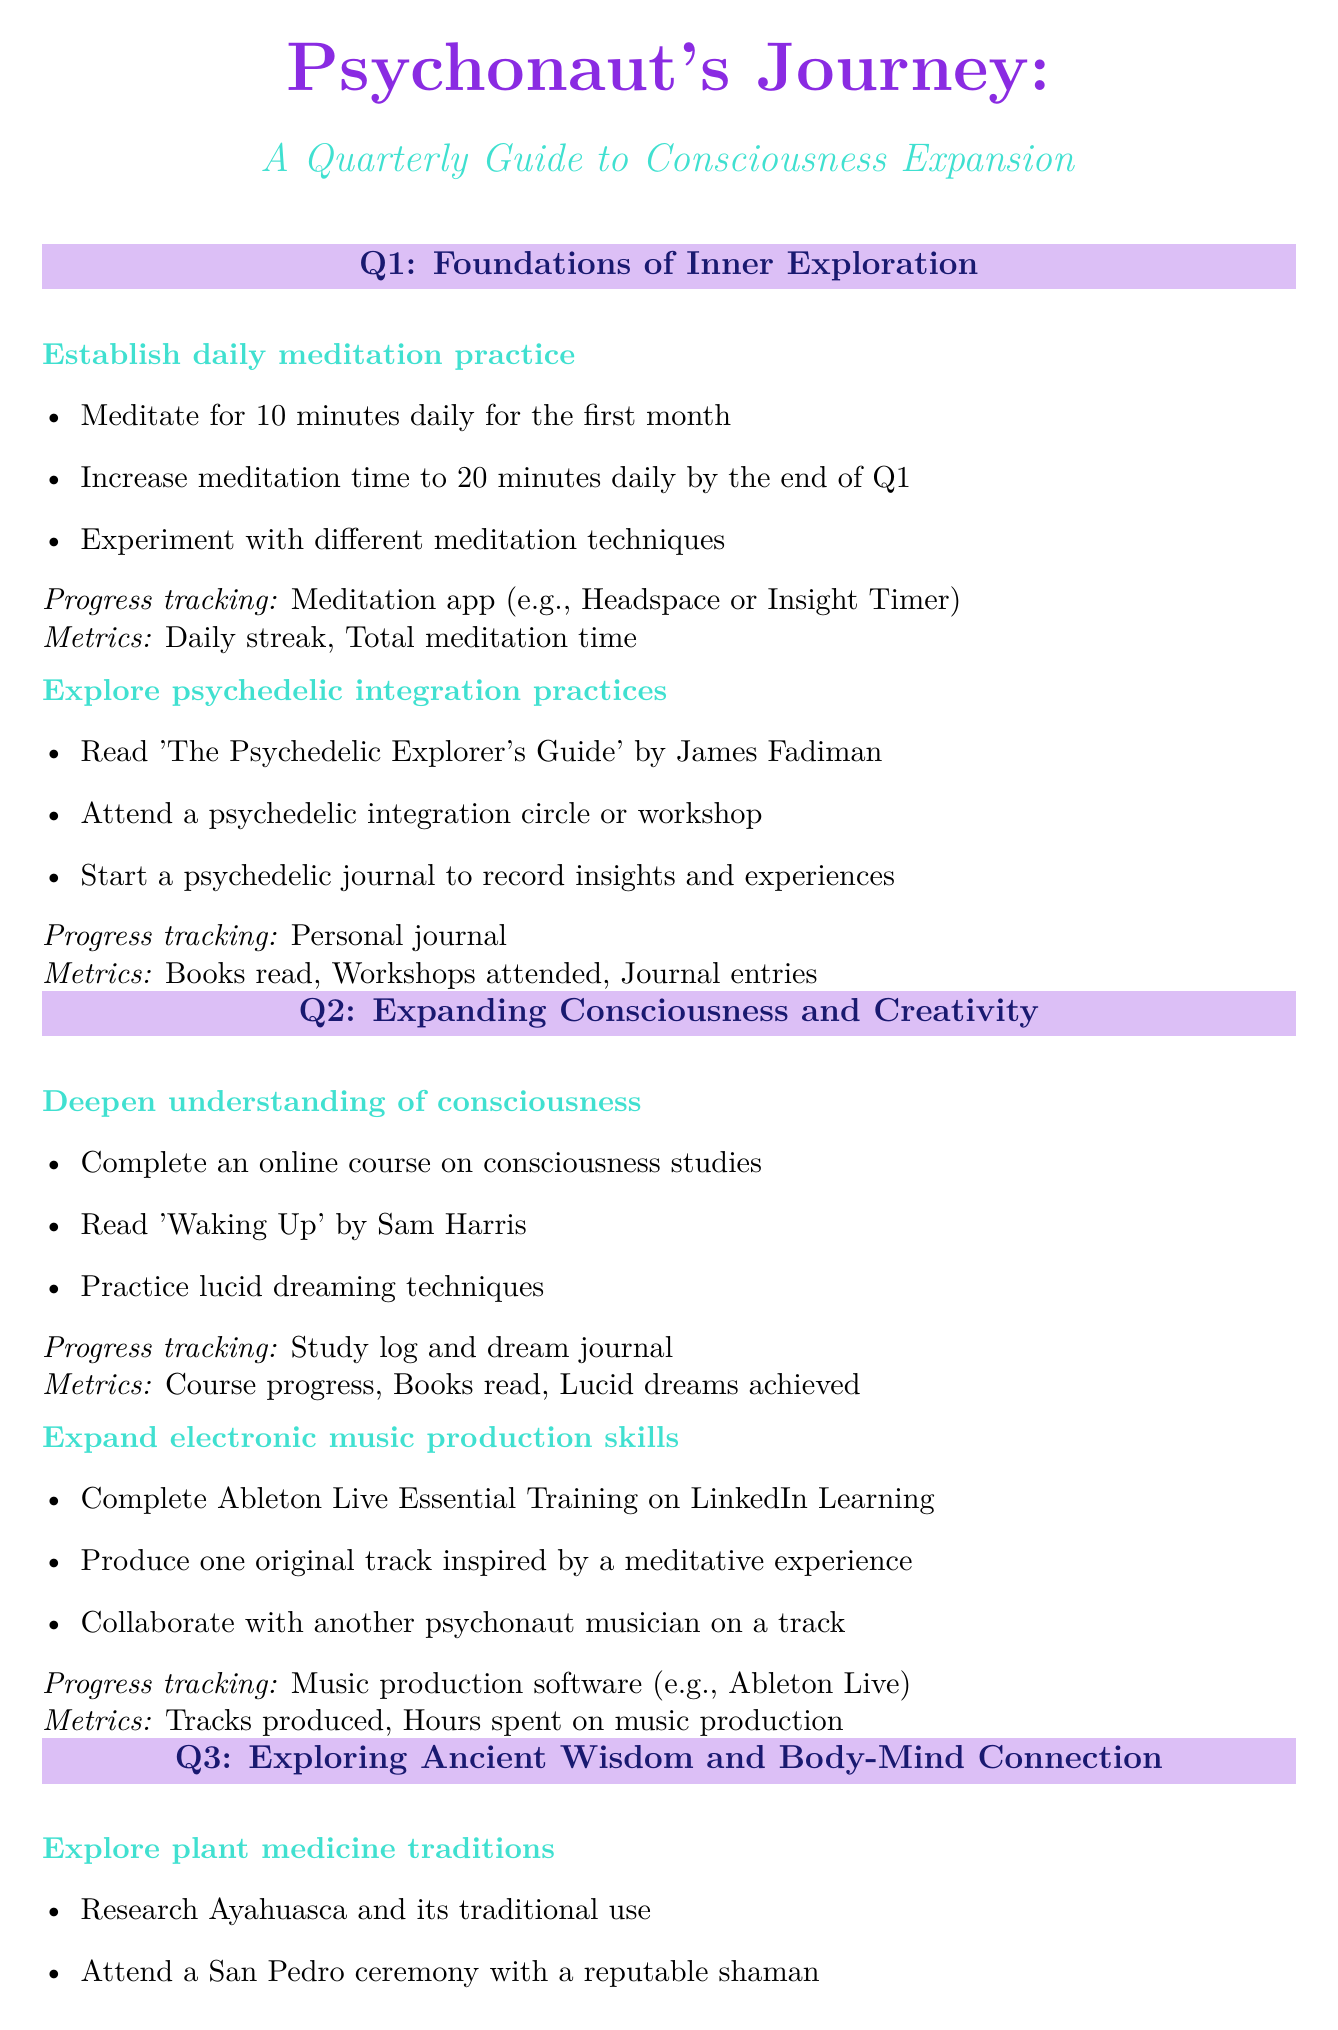what is the first milestone for establishing a daily meditation practice? The first milestone for establishing a daily meditation practice is to meditate for 10 minutes daily for the first month.
Answer: Meditate for 10 minutes daily for the first month how many goals are set for Q2? The document lists two goals for Q2 under the section titled "Expanding Consciousness and Creativity."
Answer: 2 what is the method for tracking progress in Q3's goal of enhancing mind-body connection? The method for tracking progress in enhancing mind-body connection is through a fitness tracking app (e.g., MyFitnessPal).
Answer: Fitness tracking app (e.g., MyFitnessPal) which book is recommended for exploring psychedelic integration practices? The book recommended for exploring psychedelic integration practices is "The Psychedelic Explorer's Guide" by James Fadiman.
Answer: The Psychedelic Explorer's Guide by James Fadiman how many milestones are there for the goal of integrating spiritual practices into daily life? There are three milestones for the goal of integrating spiritual practices into daily life.
Answer: 3 what is the first milestone under the goal of expanding electronic music production skills? The first milestone under that goal is to complete Ableton Live Essential Training on LinkedIn Learning.
Answer: Complete Ableton Live Essential Training on LinkedIn Learning which quarter focuses on exploring plant medicine traditions? Exploring plant medicine traditions is the goal for Q3.
Answer: Q3 how is progress tracked for the goal of deepening understanding of consciousness? Progress is tracked using a study log and dream journal for that goal.
Answer: Study log and dream journal 